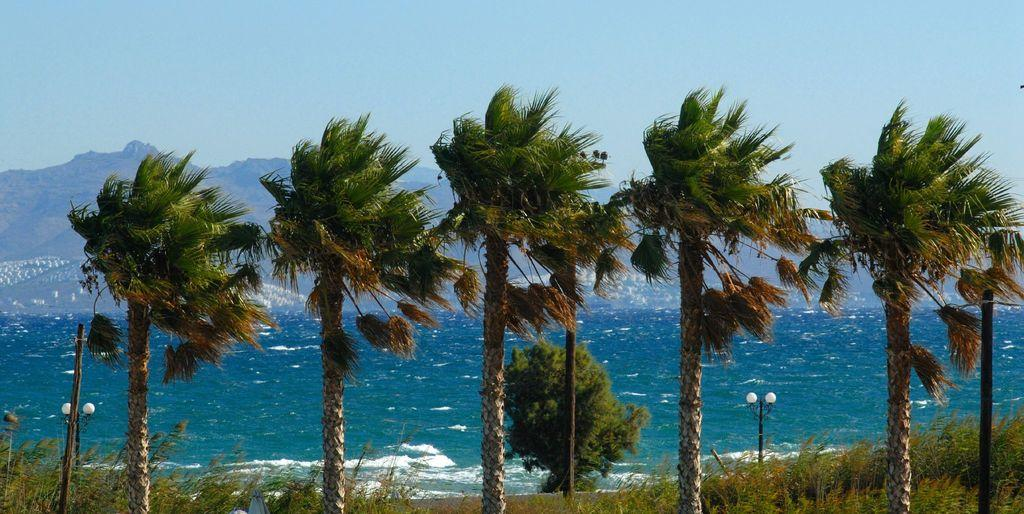What type of natural elements can be seen in the image? There are trees and plants visible in the image. What man-made structures can be seen in the image? There are street lights and a pole visible in the image. What is the water feature in the image? There is water visible in the image. What can be seen in the background of the image? There are mountains and the sky visible in the background of the image. Where is the boy standing with his umbrella in the image? There is no boy or umbrella present in the image. What type of spot is visible on the mountain in the image? There is no spot visible on the mountain in the image. 